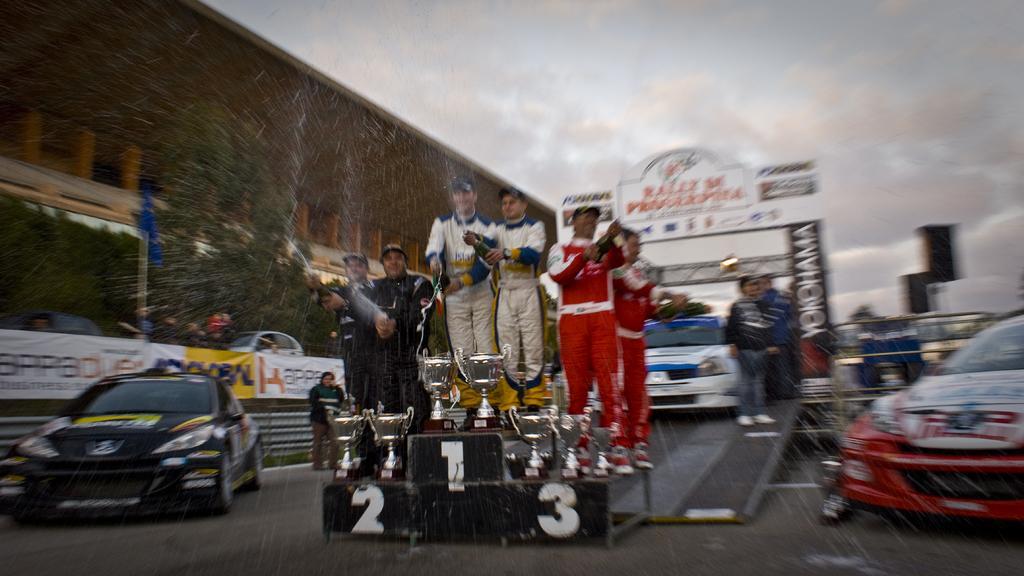In one or two sentences, can you explain what this image depicts? In this image I can see a platform on which there are numbers and I can see the cups. I can also see few men standing on it and they're holding bottles in their hands. On the both sides of this picture I can see the cars and in the background I can see few more cars and few people. In the middle of this picture I can see the boards on which there is something written. On the top of this picture I can see the sky which is cloudy and I see that this image is a bit blurry. 